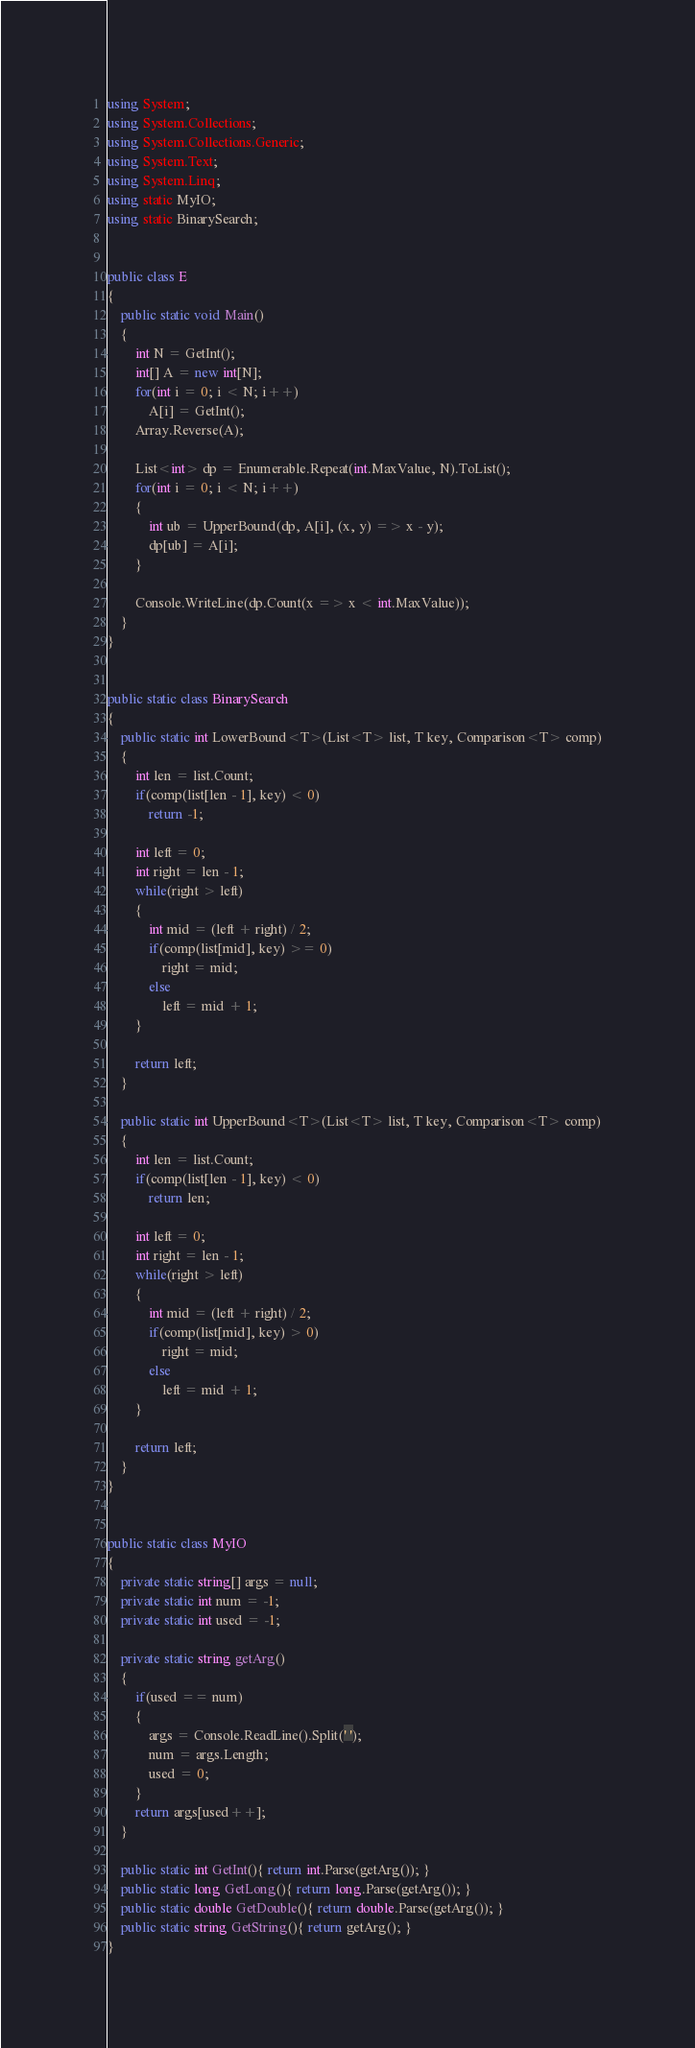Convert code to text. <code><loc_0><loc_0><loc_500><loc_500><_C#_>using System;
using System.Collections;
using System.Collections.Generic;
using System.Text;
using System.Linq;
using static MyIO;
using static BinarySearch;


public class E
{
	public static void Main()
	{
		int N = GetInt();
		int[] A = new int[N];
		for(int i = 0; i < N; i++)
			A[i] = GetInt();
		Array.Reverse(A);

		List<int> dp = Enumerable.Repeat(int.MaxValue, N).ToList();
		for(int i = 0; i < N; i++)
		{
			int ub = UpperBound(dp, A[i], (x, y) => x - y);
			dp[ub] = A[i];
		}

		Console.WriteLine(dp.Count(x => x < int.MaxValue));
	}
}


public static class BinarySearch
{
	public static int LowerBound<T>(List<T> list, T key, Comparison<T> comp)
	{
		int len = list.Count;
		if(comp(list[len - 1], key) < 0)
			return -1;

		int left = 0;
		int right = len - 1;
		while(right > left)
		{
			int mid = (left + right) / 2;
			if(comp(list[mid], key) >= 0)
				right = mid;
			else
				left = mid + 1;
		}

		return left;
	}

	public static int UpperBound<T>(List<T> list, T key, Comparison<T> comp)
	{
		int len = list.Count;
		if(comp(list[len - 1], key) < 0)
			return len;

		int left = 0;
		int right = len - 1;
		while(right > left)
		{
			int mid = (left + right) / 2;
			if(comp(list[mid], key) > 0)						
				right = mid;
			else			
				left = mid + 1;	
		}

		return left;
	}
}


public static class MyIO
{
	private static string[] args = null;
	private static int num = -1;
	private static int used = -1;

	private static string getArg()
	{
		if(used == num)
		{
			args = Console.ReadLine().Split(' ');
			num = args.Length;
			used = 0;
		}
		return args[used++];
	}

	public static int GetInt(){ return int.Parse(getArg()); }
	public static long GetLong(){ return long.Parse(getArg()); }
	public static double GetDouble(){ return double.Parse(getArg()); }
	public static string GetString(){ return getArg(); }
}



</code> 